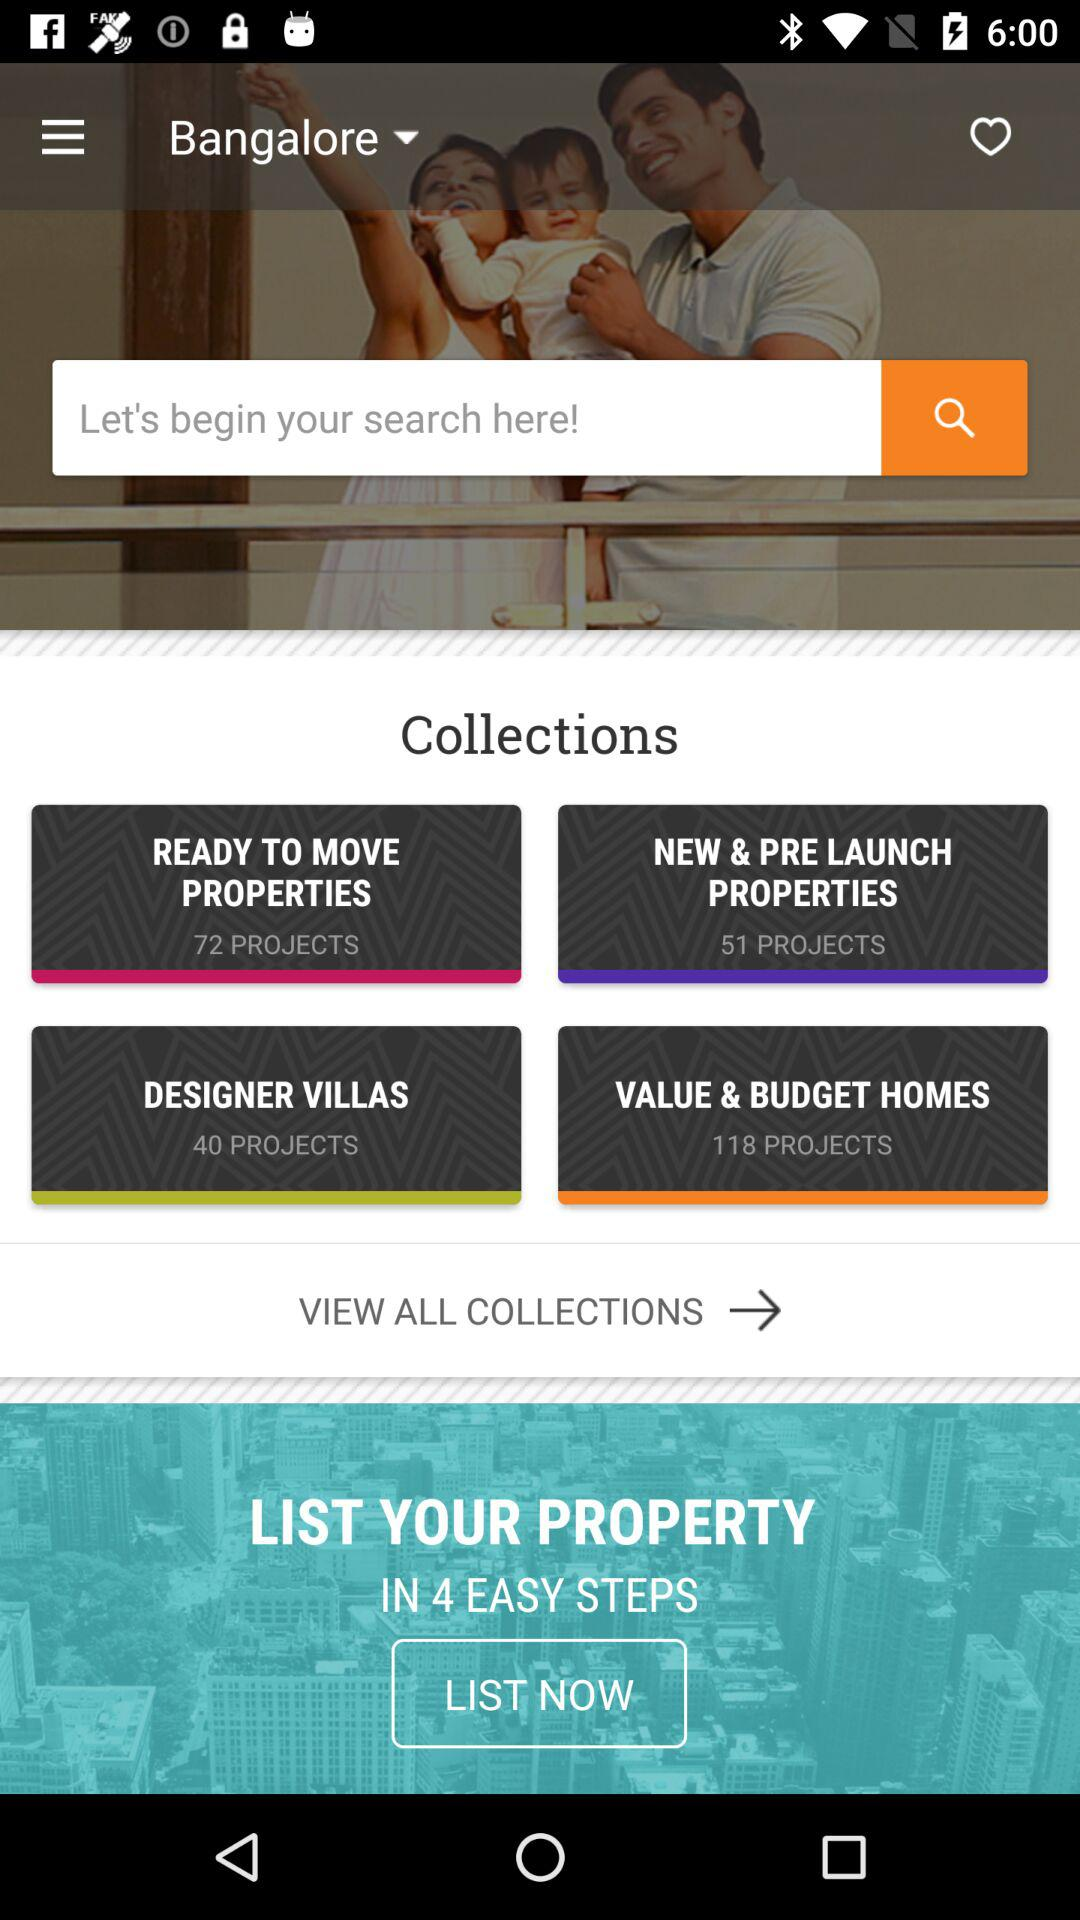How many steps are there to list a property? There are 4 steps to list a property. 